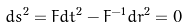<formula> <loc_0><loc_0><loc_500><loc_500>d s ^ { 2 } = F d t ^ { 2 } - F ^ { - 1 } d r ^ { 2 } = 0</formula> 